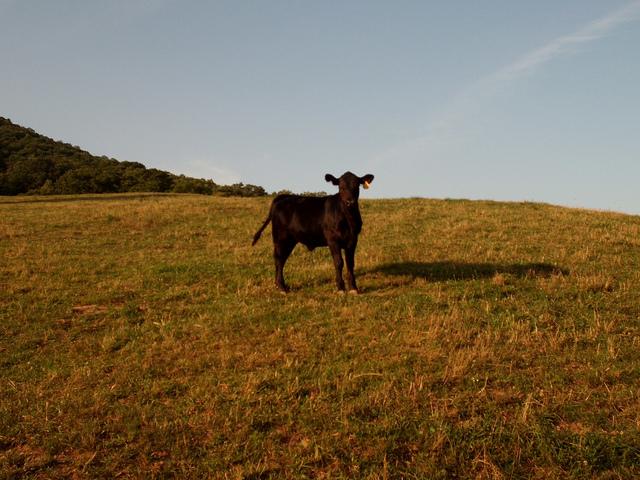Is that smoke in the sky?
Write a very short answer. No. What is in the background?
Short answer required. Sky. What type of terrain is pictured?
Quick response, please. Field. What color are the grass?
Concise answer only. Green. What is the animal in the image?
Quick response, please. Cow. Is the cow fenced in?
Give a very brief answer. No. What are the colors on this cow?
Be succinct. Brown. How many cows?
Be succinct. 1. What are on the cow's ears?
Write a very short answer. Tag. How many animals are in the photo?
Write a very short answer. 1. What color is the cow?
Keep it brief. Brown. How many animals are pictured?
Give a very brief answer. 1. What is this cow doing?
Answer briefly. Standing. What type of animal is in the picture?
Keep it brief. Cow. Does this cow have an ear tag?
Quick response, please. Yes. Does the cow have tags in both ears?
Keep it brief. No. What is the cow doing?
Answer briefly. Standing. Did the cow move by itself to the field?
Concise answer only. Yes. How many horses are there?
Give a very brief answer. 0. What kind of animal is in the picture?
Keep it brief. Cow. Is there a barn in the background?
Keep it brief. No. Is this cow hungry?
Short answer required. No. Is this a fat cow in the front?
Be succinct. No. Is the cow waiting for someone?
Be succinct. No. What color is the grass?
Keep it brief. Green. 